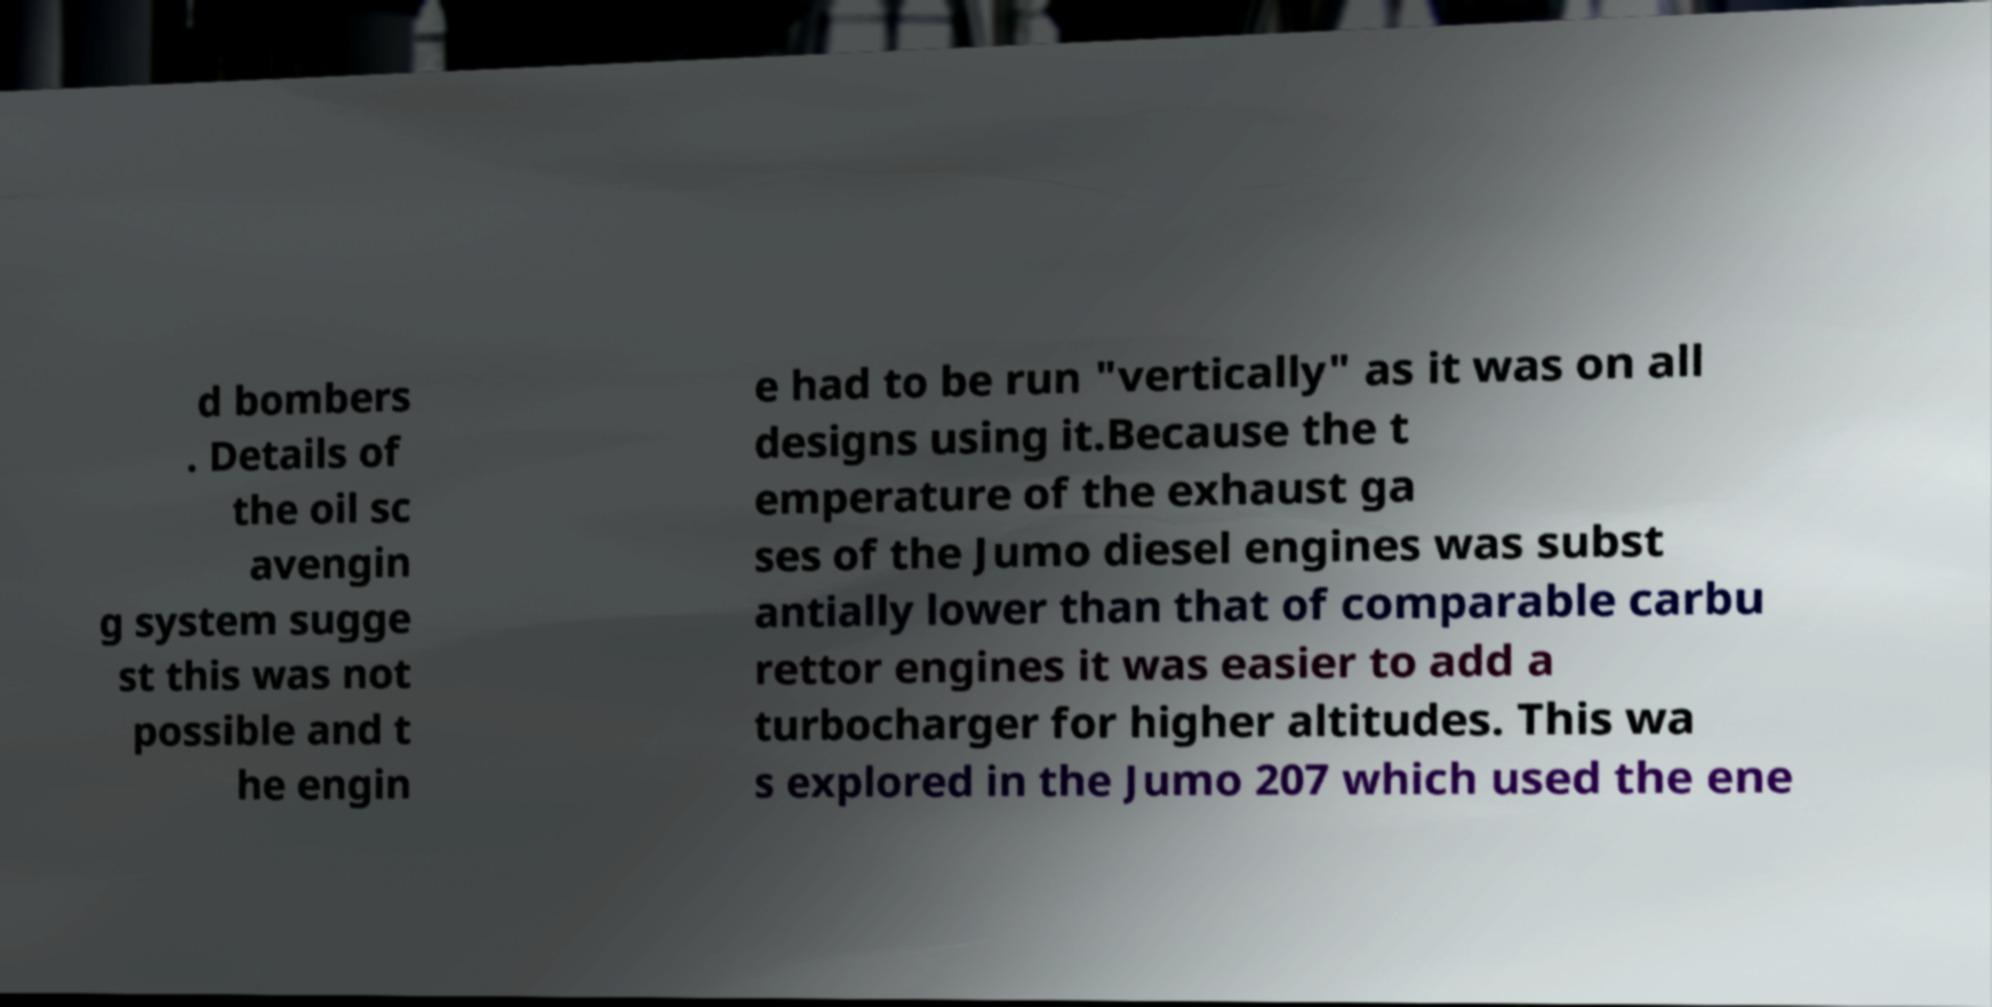Please identify and transcribe the text found in this image. d bombers . Details of the oil sc avengin g system sugge st this was not possible and t he engin e had to be run "vertically" as it was on all designs using it.Because the t emperature of the exhaust ga ses of the Jumo diesel engines was subst antially lower than that of comparable carbu rettor engines it was easier to add a turbocharger for higher altitudes. This wa s explored in the Jumo 207 which used the ene 